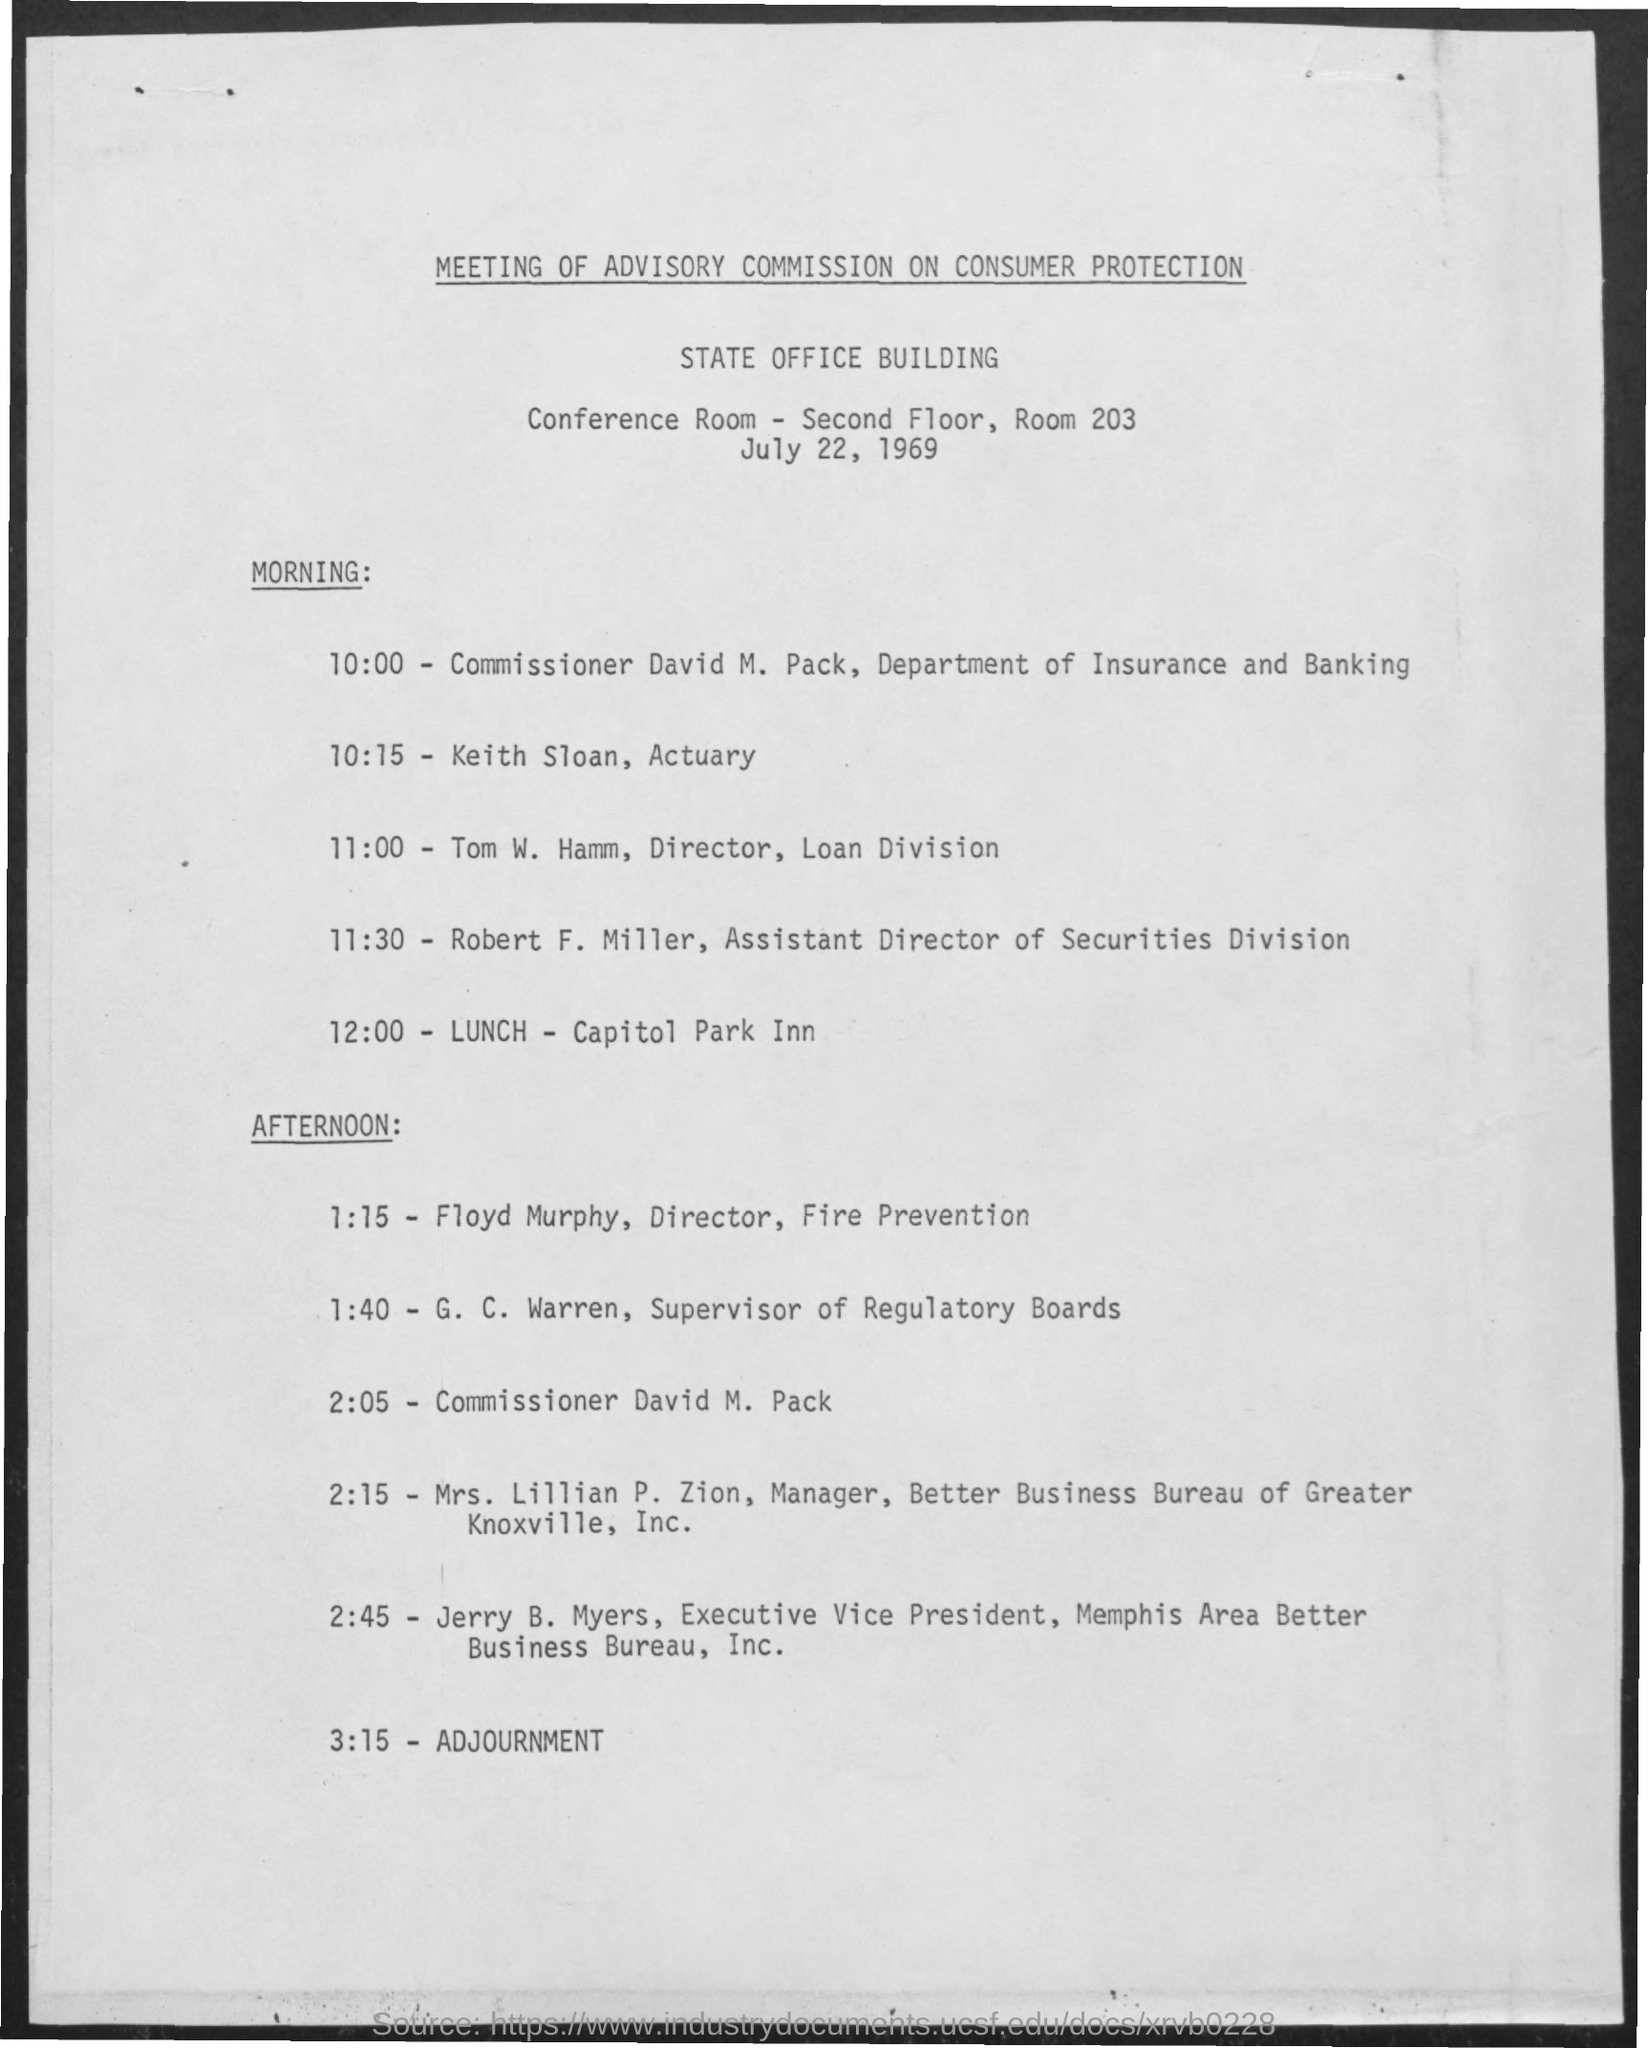What is the conference room no
Give a very brief answer. 203. What is the time of adjournment
Keep it short and to the point. 3:15. Who is director of loan division ?
Provide a succinct answer. Tom W. Hamm. What is the lunch time
Keep it short and to the point. 12:00. Where  is the venue for lunch
Ensure brevity in your answer.  Capitol Park Inn. Who is the assistant director of securities division
Give a very brief answer. Robert F .Miller. Who is the director of  fire prevention
Your answer should be very brief. Floyd Murphy. Who is the commissioner ?
Give a very brief answer. David M pack. 